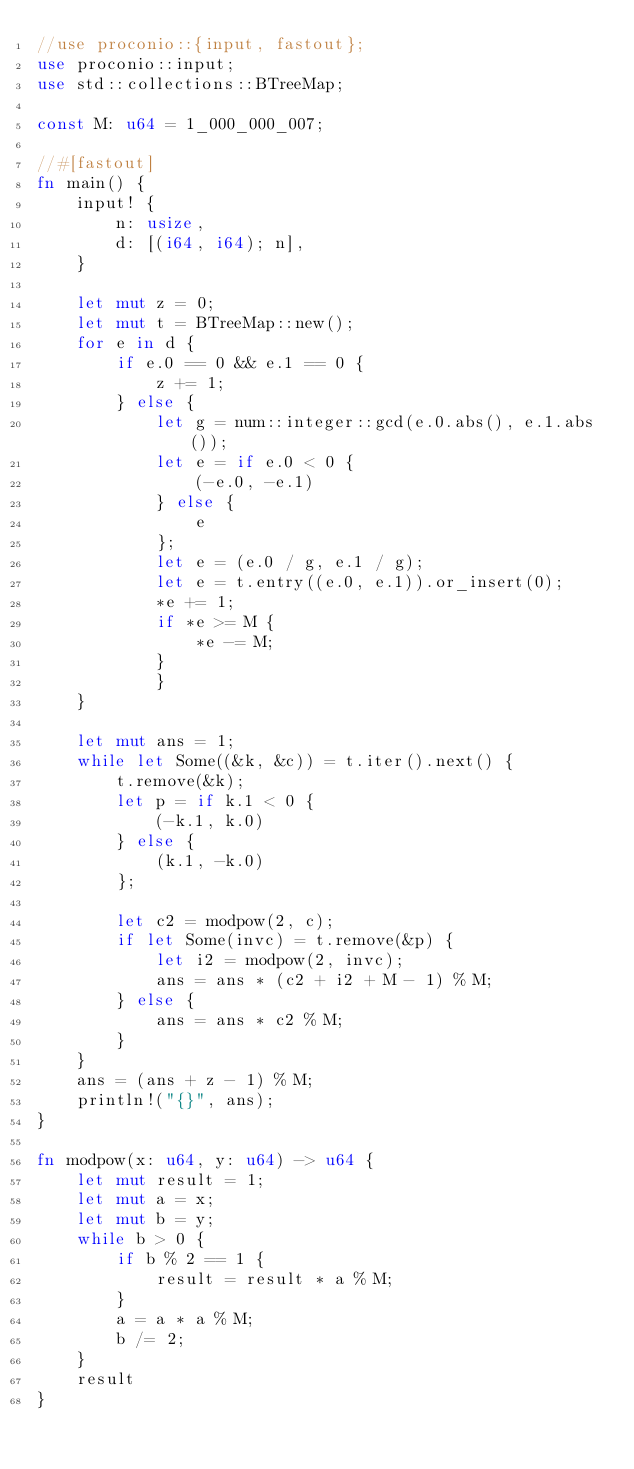<code> <loc_0><loc_0><loc_500><loc_500><_Rust_>//use proconio::{input, fastout};
use proconio::input;
use std::collections::BTreeMap;

const M: u64 = 1_000_000_007;

//#[fastout]
fn main() {
    input! {
        n: usize,
        d: [(i64, i64); n],
    }

    let mut z = 0;
    let mut t = BTreeMap::new();
    for e in d {
        if e.0 == 0 && e.1 == 0 {
            z += 1;
        } else {
            let g = num::integer::gcd(e.0.abs(), e.1.abs());
            let e = if e.0 < 0 {
                (-e.0, -e.1)
            } else {
                e
            };
            let e = (e.0 / g, e.1 / g);
            let e = t.entry((e.0, e.1)).or_insert(0);
            *e += 1;
            if *e >= M {
                *e -= M;
            }
            }
    }

    let mut ans = 1;
    while let Some((&k, &c)) = t.iter().next() {
        t.remove(&k);
        let p = if k.1 < 0 {
            (-k.1, k.0)
        } else {
            (k.1, -k.0)
        };

        let c2 = modpow(2, c);
        if let Some(invc) = t.remove(&p) {
            let i2 = modpow(2, invc);
            ans = ans * (c2 + i2 + M - 1) % M;
        } else {
            ans = ans * c2 % M;
        }
    }
    ans = (ans + z - 1) % M;
    println!("{}", ans);
}

fn modpow(x: u64, y: u64) -> u64 {
    let mut result = 1;
    let mut a = x;
    let mut b = y;
    while b > 0 {
        if b % 2 == 1 {
            result = result * a % M;
        }
        a = a * a % M;
        b /= 2;
    }
    result
}
</code> 